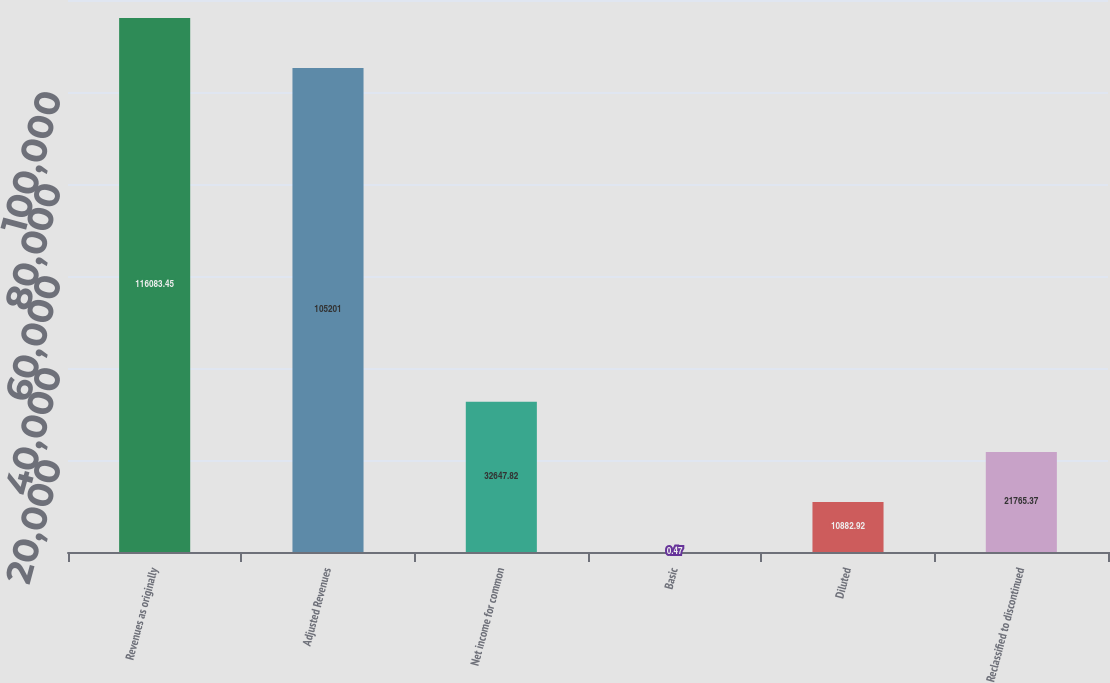<chart> <loc_0><loc_0><loc_500><loc_500><bar_chart><fcel>Revenues as originally<fcel>Adjusted Revenues<fcel>Net income for common<fcel>Basic<fcel>Diluted<fcel>Reclassified to discontinued<nl><fcel>116083<fcel>105201<fcel>32647.8<fcel>0.47<fcel>10882.9<fcel>21765.4<nl></chart> 